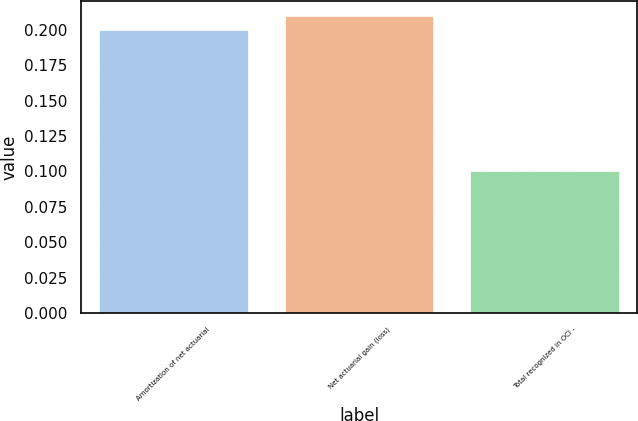Convert chart to OTSL. <chart><loc_0><loc_0><loc_500><loc_500><bar_chart><fcel>Amortization of net actuarial<fcel>Net actuarial gain (loss)<fcel>Total recognized in OCI -<nl><fcel>0.2<fcel>0.21<fcel>0.1<nl></chart> 